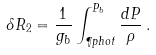Convert formula to latex. <formula><loc_0><loc_0><loc_500><loc_500>\delta R _ { 2 } = \frac { 1 } { g _ { b } } \int _ { \P p h o t } ^ { P _ { b } } \frac { d P } { \rho } \, .</formula> 